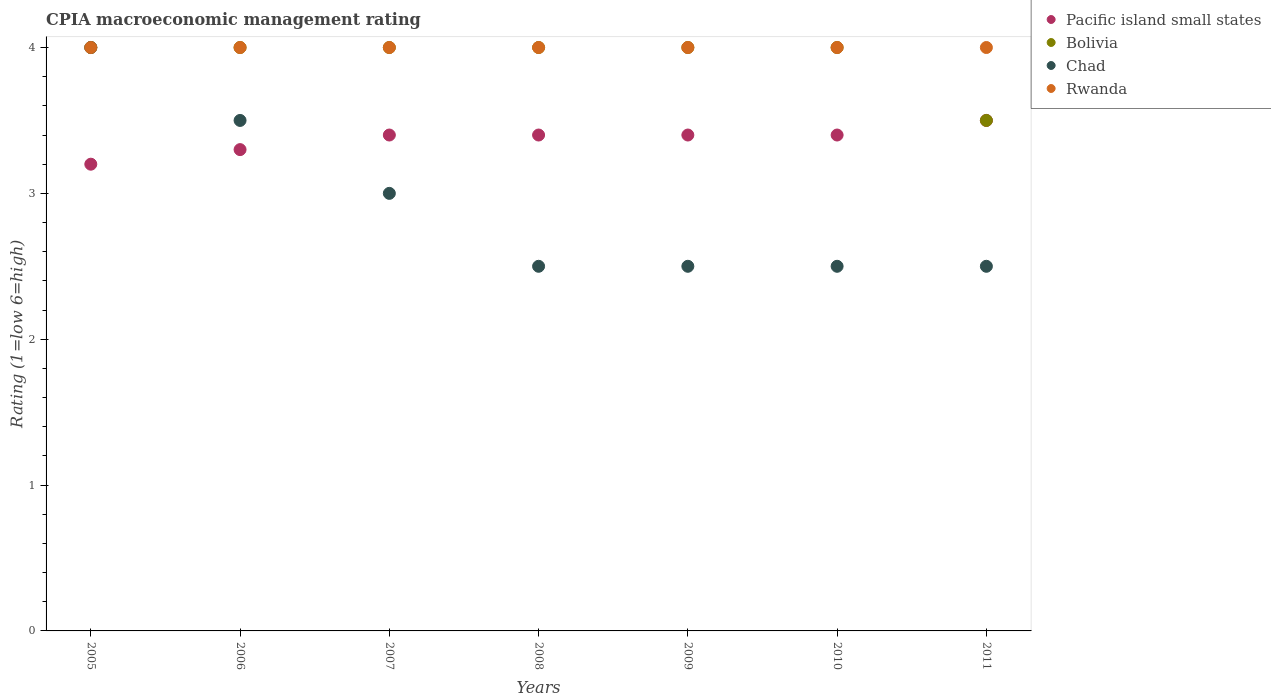Is the number of dotlines equal to the number of legend labels?
Your answer should be compact. Yes. What is the CPIA rating in Pacific island small states in 2010?
Ensure brevity in your answer.  3.4. Across all years, what is the minimum CPIA rating in Bolivia?
Ensure brevity in your answer.  3.5. In which year was the CPIA rating in Bolivia maximum?
Make the answer very short. 2005. In which year was the CPIA rating in Pacific island small states minimum?
Give a very brief answer. 2005. What is the total CPIA rating in Chad in the graph?
Provide a succinct answer. 20.5. What is the difference between the CPIA rating in Chad in 2008 and that in 2011?
Make the answer very short. 0. What is the difference between the CPIA rating in Pacific island small states in 2005 and the CPIA rating in Bolivia in 2009?
Your answer should be very brief. -0.8. In how many years, is the CPIA rating in Chad greater than 1.8?
Your answer should be very brief. 7. Is the CPIA rating in Pacific island small states in 2008 less than that in 2009?
Offer a terse response. No. Is the sum of the CPIA rating in Bolivia in 2009 and 2010 greater than the maximum CPIA rating in Chad across all years?
Give a very brief answer. Yes. Is it the case that in every year, the sum of the CPIA rating in Rwanda and CPIA rating in Bolivia  is greater than the sum of CPIA rating in Pacific island small states and CPIA rating in Chad?
Make the answer very short. No. Is it the case that in every year, the sum of the CPIA rating in Chad and CPIA rating in Pacific island small states  is greater than the CPIA rating in Bolivia?
Keep it short and to the point. Yes. Is the CPIA rating in Rwanda strictly greater than the CPIA rating in Chad over the years?
Make the answer very short. No. How many dotlines are there?
Provide a succinct answer. 4. How many years are there in the graph?
Ensure brevity in your answer.  7. What is the difference between two consecutive major ticks on the Y-axis?
Give a very brief answer. 1. Does the graph contain any zero values?
Keep it short and to the point. No. What is the title of the graph?
Ensure brevity in your answer.  CPIA macroeconomic management rating. What is the Rating (1=low 6=high) of Bolivia in 2005?
Provide a succinct answer. 4. What is the Rating (1=low 6=high) in Pacific island small states in 2006?
Your response must be concise. 3.3. What is the Rating (1=low 6=high) in Bolivia in 2006?
Keep it short and to the point. 4. What is the Rating (1=low 6=high) in Chad in 2006?
Offer a terse response. 3.5. What is the Rating (1=low 6=high) in Pacific island small states in 2007?
Your answer should be very brief. 3.4. What is the Rating (1=low 6=high) of Chad in 2008?
Offer a very short reply. 2.5. What is the Rating (1=low 6=high) in Rwanda in 2008?
Make the answer very short. 4. What is the Rating (1=low 6=high) of Pacific island small states in 2009?
Offer a terse response. 3.4. What is the Rating (1=low 6=high) in Rwanda in 2010?
Your answer should be very brief. 4. What is the Rating (1=low 6=high) of Chad in 2011?
Offer a very short reply. 2.5. What is the Rating (1=low 6=high) of Rwanda in 2011?
Offer a terse response. 4. Across all years, what is the maximum Rating (1=low 6=high) in Pacific island small states?
Your answer should be compact. 3.5. Across all years, what is the minimum Rating (1=low 6=high) of Pacific island small states?
Keep it short and to the point. 3.2. Across all years, what is the minimum Rating (1=low 6=high) of Bolivia?
Your answer should be very brief. 3.5. Across all years, what is the minimum Rating (1=low 6=high) of Chad?
Give a very brief answer. 2.5. What is the total Rating (1=low 6=high) in Pacific island small states in the graph?
Keep it short and to the point. 23.6. What is the total Rating (1=low 6=high) in Bolivia in the graph?
Offer a very short reply. 27.5. What is the difference between the Rating (1=low 6=high) of Bolivia in 2005 and that in 2006?
Your response must be concise. 0. What is the difference between the Rating (1=low 6=high) in Rwanda in 2005 and that in 2006?
Ensure brevity in your answer.  0. What is the difference between the Rating (1=low 6=high) of Pacific island small states in 2005 and that in 2007?
Ensure brevity in your answer.  -0.2. What is the difference between the Rating (1=low 6=high) in Bolivia in 2005 and that in 2007?
Provide a short and direct response. 0. What is the difference between the Rating (1=low 6=high) in Chad in 2005 and that in 2007?
Your answer should be compact. 1. What is the difference between the Rating (1=low 6=high) in Pacific island small states in 2005 and that in 2008?
Your answer should be very brief. -0.2. What is the difference between the Rating (1=low 6=high) in Rwanda in 2005 and that in 2008?
Keep it short and to the point. 0. What is the difference between the Rating (1=low 6=high) in Pacific island small states in 2005 and that in 2009?
Offer a very short reply. -0.2. What is the difference between the Rating (1=low 6=high) in Bolivia in 2005 and that in 2009?
Provide a succinct answer. 0. What is the difference between the Rating (1=low 6=high) in Chad in 2005 and that in 2009?
Make the answer very short. 1.5. What is the difference between the Rating (1=low 6=high) in Chad in 2005 and that in 2010?
Offer a terse response. 1.5. What is the difference between the Rating (1=low 6=high) of Rwanda in 2005 and that in 2010?
Your answer should be very brief. 0. What is the difference between the Rating (1=low 6=high) of Chad in 2005 and that in 2011?
Your response must be concise. 1.5. What is the difference between the Rating (1=low 6=high) of Rwanda in 2005 and that in 2011?
Offer a terse response. 0. What is the difference between the Rating (1=low 6=high) in Pacific island small states in 2006 and that in 2007?
Your response must be concise. -0.1. What is the difference between the Rating (1=low 6=high) in Chad in 2006 and that in 2007?
Your response must be concise. 0.5. What is the difference between the Rating (1=low 6=high) in Rwanda in 2006 and that in 2007?
Your response must be concise. 0. What is the difference between the Rating (1=low 6=high) of Bolivia in 2006 and that in 2008?
Provide a short and direct response. 0. What is the difference between the Rating (1=low 6=high) in Chad in 2006 and that in 2008?
Offer a terse response. 1. What is the difference between the Rating (1=low 6=high) in Bolivia in 2006 and that in 2009?
Give a very brief answer. 0. What is the difference between the Rating (1=low 6=high) in Rwanda in 2006 and that in 2009?
Provide a succinct answer. 0. What is the difference between the Rating (1=low 6=high) of Bolivia in 2006 and that in 2011?
Your answer should be compact. 0.5. What is the difference between the Rating (1=low 6=high) of Bolivia in 2007 and that in 2008?
Your response must be concise. 0. What is the difference between the Rating (1=low 6=high) of Chad in 2007 and that in 2008?
Provide a succinct answer. 0.5. What is the difference between the Rating (1=low 6=high) in Bolivia in 2007 and that in 2009?
Offer a very short reply. 0. What is the difference between the Rating (1=low 6=high) of Pacific island small states in 2007 and that in 2010?
Provide a short and direct response. 0. What is the difference between the Rating (1=low 6=high) in Bolivia in 2007 and that in 2010?
Provide a succinct answer. 0. What is the difference between the Rating (1=low 6=high) in Chad in 2007 and that in 2010?
Offer a very short reply. 0.5. What is the difference between the Rating (1=low 6=high) in Rwanda in 2007 and that in 2010?
Keep it short and to the point. 0. What is the difference between the Rating (1=low 6=high) of Bolivia in 2007 and that in 2011?
Your answer should be very brief. 0.5. What is the difference between the Rating (1=low 6=high) in Chad in 2007 and that in 2011?
Your answer should be compact. 0.5. What is the difference between the Rating (1=low 6=high) of Rwanda in 2007 and that in 2011?
Your answer should be compact. 0. What is the difference between the Rating (1=low 6=high) of Pacific island small states in 2008 and that in 2009?
Provide a short and direct response. 0. What is the difference between the Rating (1=low 6=high) of Bolivia in 2008 and that in 2009?
Your answer should be very brief. 0. What is the difference between the Rating (1=low 6=high) of Chad in 2008 and that in 2009?
Provide a succinct answer. 0. What is the difference between the Rating (1=low 6=high) in Pacific island small states in 2008 and that in 2010?
Ensure brevity in your answer.  0. What is the difference between the Rating (1=low 6=high) of Bolivia in 2008 and that in 2010?
Make the answer very short. 0. What is the difference between the Rating (1=low 6=high) in Bolivia in 2008 and that in 2011?
Your answer should be very brief. 0.5. What is the difference between the Rating (1=low 6=high) of Rwanda in 2008 and that in 2011?
Offer a very short reply. 0. What is the difference between the Rating (1=low 6=high) in Pacific island small states in 2009 and that in 2010?
Keep it short and to the point. 0. What is the difference between the Rating (1=low 6=high) in Bolivia in 2009 and that in 2010?
Your response must be concise. 0. What is the difference between the Rating (1=low 6=high) of Chad in 2009 and that in 2010?
Keep it short and to the point. 0. What is the difference between the Rating (1=low 6=high) of Rwanda in 2009 and that in 2010?
Offer a terse response. 0. What is the difference between the Rating (1=low 6=high) of Pacific island small states in 2009 and that in 2011?
Your answer should be compact. -0.1. What is the difference between the Rating (1=low 6=high) in Chad in 2009 and that in 2011?
Give a very brief answer. 0. What is the difference between the Rating (1=low 6=high) in Rwanda in 2009 and that in 2011?
Your response must be concise. 0. What is the difference between the Rating (1=low 6=high) of Bolivia in 2010 and that in 2011?
Offer a terse response. 0.5. What is the difference between the Rating (1=low 6=high) in Chad in 2010 and that in 2011?
Offer a very short reply. 0. What is the difference between the Rating (1=low 6=high) of Rwanda in 2010 and that in 2011?
Provide a short and direct response. 0. What is the difference between the Rating (1=low 6=high) of Pacific island small states in 2005 and the Rating (1=low 6=high) of Bolivia in 2006?
Provide a short and direct response. -0.8. What is the difference between the Rating (1=low 6=high) in Bolivia in 2005 and the Rating (1=low 6=high) in Chad in 2006?
Your answer should be very brief. 0.5. What is the difference between the Rating (1=low 6=high) of Pacific island small states in 2005 and the Rating (1=low 6=high) of Bolivia in 2007?
Ensure brevity in your answer.  -0.8. What is the difference between the Rating (1=low 6=high) of Pacific island small states in 2005 and the Rating (1=low 6=high) of Rwanda in 2007?
Offer a terse response. -0.8. What is the difference between the Rating (1=low 6=high) in Bolivia in 2005 and the Rating (1=low 6=high) in Chad in 2007?
Make the answer very short. 1. What is the difference between the Rating (1=low 6=high) in Pacific island small states in 2005 and the Rating (1=low 6=high) in Bolivia in 2008?
Offer a terse response. -0.8. What is the difference between the Rating (1=low 6=high) of Pacific island small states in 2005 and the Rating (1=low 6=high) of Rwanda in 2008?
Your response must be concise. -0.8. What is the difference between the Rating (1=low 6=high) of Bolivia in 2005 and the Rating (1=low 6=high) of Chad in 2008?
Offer a very short reply. 1.5. What is the difference between the Rating (1=low 6=high) in Bolivia in 2005 and the Rating (1=low 6=high) in Rwanda in 2008?
Offer a terse response. 0. What is the difference between the Rating (1=low 6=high) in Chad in 2005 and the Rating (1=low 6=high) in Rwanda in 2008?
Provide a short and direct response. 0. What is the difference between the Rating (1=low 6=high) of Pacific island small states in 2005 and the Rating (1=low 6=high) of Bolivia in 2009?
Keep it short and to the point. -0.8. What is the difference between the Rating (1=low 6=high) of Pacific island small states in 2005 and the Rating (1=low 6=high) of Chad in 2009?
Your response must be concise. 0.7. What is the difference between the Rating (1=low 6=high) of Bolivia in 2005 and the Rating (1=low 6=high) of Chad in 2009?
Ensure brevity in your answer.  1.5. What is the difference between the Rating (1=low 6=high) in Pacific island small states in 2005 and the Rating (1=low 6=high) in Bolivia in 2010?
Ensure brevity in your answer.  -0.8. What is the difference between the Rating (1=low 6=high) in Pacific island small states in 2005 and the Rating (1=low 6=high) in Rwanda in 2010?
Your answer should be very brief. -0.8. What is the difference between the Rating (1=low 6=high) of Chad in 2005 and the Rating (1=low 6=high) of Rwanda in 2010?
Provide a succinct answer. 0. What is the difference between the Rating (1=low 6=high) of Pacific island small states in 2005 and the Rating (1=low 6=high) of Bolivia in 2011?
Offer a very short reply. -0.3. What is the difference between the Rating (1=low 6=high) of Pacific island small states in 2005 and the Rating (1=low 6=high) of Rwanda in 2011?
Make the answer very short. -0.8. What is the difference between the Rating (1=low 6=high) in Bolivia in 2005 and the Rating (1=low 6=high) in Chad in 2011?
Offer a terse response. 1.5. What is the difference between the Rating (1=low 6=high) in Bolivia in 2005 and the Rating (1=low 6=high) in Rwanda in 2011?
Offer a terse response. 0. What is the difference between the Rating (1=low 6=high) in Pacific island small states in 2006 and the Rating (1=low 6=high) in Bolivia in 2007?
Your response must be concise. -0.7. What is the difference between the Rating (1=low 6=high) of Pacific island small states in 2006 and the Rating (1=low 6=high) of Chad in 2007?
Make the answer very short. 0.3. What is the difference between the Rating (1=low 6=high) of Bolivia in 2006 and the Rating (1=low 6=high) of Rwanda in 2007?
Keep it short and to the point. 0. What is the difference between the Rating (1=low 6=high) in Pacific island small states in 2006 and the Rating (1=low 6=high) in Rwanda in 2008?
Offer a very short reply. -0.7. What is the difference between the Rating (1=low 6=high) of Bolivia in 2006 and the Rating (1=low 6=high) of Rwanda in 2008?
Give a very brief answer. 0. What is the difference between the Rating (1=low 6=high) in Pacific island small states in 2006 and the Rating (1=low 6=high) in Bolivia in 2009?
Offer a very short reply. -0.7. What is the difference between the Rating (1=low 6=high) of Bolivia in 2006 and the Rating (1=low 6=high) of Chad in 2009?
Your answer should be very brief. 1.5. What is the difference between the Rating (1=low 6=high) in Bolivia in 2006 and the Rating (1=low 6=high) in Rwanda in 2009?
Offer a terse response. 0. What is the difference between the Rating (1=low 6=high) in Chad in 2006 and the Rating (1=low 6=high) in Rwanda in 2009?
Your response must be concise. -0.5. What is the difference between the Rating (1=low 6=high) in Pacific island small states in 2006 and the Rating (1=low 6=high) in Bolivia in 2010?
Keep it short and to the point. -0.7. What is the difference between the Rating (1=low 6=high) in Pacific island small states in 2006 and the Rating (1=low 6=high) in Rwanda in 2010?
Your answer should be very brief. -0.7. What is the difference between the Rating (1=low 6=high) of Bolivia in 2006 and the Rating (1=low 6=high) of Chad in 2010?
Your answer should be very brief. 1.5. What is the difference between the Rating (1=low 6=high) in Pacific island small states in 2006 and the Rating (1=low 6=high) in Bolivia in 2011?
Provide a succinct answer. -0.2. What is the difference between the Rating (1=low 6=high) of Bolivia in 2006 and the Rating (1=low 6=high) of Rwanda in 2011?
Provide a short and direct response. 0. What is the difference between the Rating (1=low 6=high) of Chad in 2006 and the Rating (1=low 6=high) of Rwanda in 2011?
Your response must be concise. -0.5. What is the difference between the Rating (1=low 6=high) of Pacific island small states in 2007 and the Rating (1=low 6=high) of Chad in 2008?
Your answer should be compact. 0.9. What is the difference between the Rating (1=low 6=high) in Pacific island small states in 2007 and the Rating (1=low 6=high) in Rwanda in 2008?
Offer a very short reply. -0.6. What is the difference between the Rating (1=low 6=high) of Chad in 2007 and the Rating (1=low 6=high) of Rwanda in 2008?
Keep it short and to the point. -1. What is the difference between the Rating (1=low 6=high) of Pacific island small states in 2007 and the Rating (1=low 6=high) of Chad in 2009?
Give a very brief answer. 0.9. What is the difference between the Rating (1=low 6=high) in Bolivia in 2007 and the Rating (1=low 6=high) in Chad in 2009?
Offer a terse response. 1.5. What is the difference between the Rating (1=low 6=high) in Bolivia in 2007 and the Rating (1=low 6=high) in Rwanda in 2009?
Keep it short and to the point. 0. What is the difference between the Rating (1=low 6=high) of Chad in 2007 and the Rating (1=low 6=high) of Rwanda in 2009?
Ensure brevity in your answer.  -1. What is the difference between the Rating (1=low 6=high) in Pacific island small states in 2007 and the Rating (1=low 6=high) in Bolivia in 2010?
Offer a very short reply. -0.6. What is the difference between the Rating (1=low 6=high) in Pacific island small states in 2007 and the Rating (1=low 6=high) in Chad in 2010?
Keep it short and to the point. 0.9. What is the difference between the Rating (1=low 6=high) of Pacific island small states in 2007 and the Rating (1=low 6=high) of Rwanda in 2010?
Your response must be concise. -0.6. What is the difference between the Rating (1=low 6=high) in Bolivia in 2007 and the Rating (1=low 6=high) in Chad in 2010?
Give a very brief answer. 1.5. What is the difference between the Rating (1=low 6=high) in Bolivia in 2007 and the Rating (1=low 6=high) in Rwanda in 2010?
Offer a terse response. 0. What is the difference between the Rating (1=low 6=high) of Pacific island small states in 2007 and the Rating (1=low 6=high) of Rwanda in 2011?
Make the answer very short. -0.6. What is the difference between the Rating (1=low 6=high) of Bolivia in 2007 and the Rating (1=low 6=high) of Rwanda in 2011?
Provide a succinct answer. 0. What is the difference between the Rating (1=low 6=high) in Pacific island small states in 2008 and the Rating (1=low 6=high) in Rwanda in 2009?
Offer a very short reply. -0.6. What is the difference between the Rating (1=low 6=high) of Bolivia in 2008 and the Rating (1=low 6=high) of Rwanda in 2009?
Offer a very short reply. 0. What is the difference between the Rating (1=low 6=high) of Pacific island small states in 2008 and the Rating (1=low 6=high) of Bolivia in 2010?
Provide a short and direct response. -0.6. What is the difference between the Rating (1=low 6=high) of Pacific island small states in 2008 and the Rating (1=low 6=high) of Chad in 2010?
Provide a succinct answer. 0.9. What is the difference between the Rating (1=low 6=high) in Bolivia in 2008 and the Rating (1=low 6=high) in Rwanda in 2010?
Give a very brief answer. 0. What is the difference between the Rating (1=low 6=high) of Pacific island small states in 2008 and the Rating (1=low 6=high) of Bolivia in 2011?
Provide a short and direct response. -0.1. What is the difference between the Rating (1=low 6=high) in Pacific island small states in 2008 and the Rating (1=low 6=high) in Rwanda in 2011?
Offer a terse response. -0.6. What is the difference between the Rating (1=low 6=high) of Bolivia in 2008 and the Rating (1=low 6=high) of Chad in 2011?
Ensure brevity in your answer.  1.5. What is the difference between the Rating (1=low 6=high) of Chad in 2008 and the Rating (1=low 6=high) of Rwanda in 2011?
Ensure brevity in your answer.  -1.5. What is the difference between the Rating (1=low 6=high) in Pacific island small states in 2009 and the Rating (1=low 6=high) in Chad in 2010?
Provide a short and direct response. 0.9. What is the difference between the Rating (1=low 6=high) of Pacific island small states in 2009 and the Rating (1=low 6=high) of Chad in 2011?
Ensure brevity in your answer.  0.9. What is the difference between the Rating (1=low 6=high) of Chad in 2009 and the Rating (1=low 6=high) of Rwanda in 2011?
Make the answer very short. -1.5. What is the difference between the Rating (1=low 6=high) in Pacific island small states in 2010 and the Rating (1=low 6=high) in Bolivia in 2011?
Give a very brief answer. -0.1. What is the difference between the Rating (1=low 6=high) in Bolivia in 2010 and the Rating (1=low 6=high) in Chad in 2011?
Offer a very short reply. 1.5. What is the average Rating (1=low 6=high) in Pacific island small states per year?
Offer a very short reply. 3.37. What is the average Rating (1=low 6=high) in Bolivia per year?
Your response must be concise. 3.93. What is the average Rating (1=low 6=high) of Chad per year?
Make the answer very short. 2.93. What is the average Rating (1=low 6=high) of Rwanda per year?
Give a very brief answer. 4. In the year 2005, what is the difference between the Rating (1=low 6=high) in Pacific island small states and Rating (1=low 6=high) in Bolivia?
Provide a succinct answer. -0.8. In the year 2005, what is the difference between the Rating (1=low 6=high) of Pacific island small states and Rating (1=low 6=high) of Chad?
Keep it short and to the point. -0.8. In the year 2006, what is the difference between the Rating (1=low 6=high) of Pacific island small states and Rating (1=low 6=high) of Bolivia?
Provide a succinct answer. -0.7. In the year 2006, what is the difference between the Rating (1=low 6=high) of Pacific island small states and Rating (1=low 6=high) of Chad?
Offer a terse response. -0.2. In the year 2006, what is the difference between the Rating (1=low 6=high) in Pacific island small states and Rating (1=low 6=high) in Rwanda?
Keep it short and to the point. -0.7. In the year 2006, what is the difference between the Rating (1=low 6=high) in Chad and Rating (1=low 6=high) in Rwanda?
Make the answer very short. -0.5. In the year 2007, what is the difference between the Rating (1=low 6=high) in Pacific island small states and Rating (1=low 6=high) in Bolivia?
Give a very brief answer. -0.6. In the year 2007, what is the difference between the Rating (1=low 6=high) in Bolivia and Rating (1=low 6=high) in Rwanda?
Provide a short and direct response. 0. In the year 2008, what is the difference between the Rating (1=low 6=high) in Bolivia and Rating (1=low 6=high) in Chad?
Provide a succinct answer. 1.5. In the year 2008, what is the difference between the Rating (1=low 6=high) in Bolivia and Rating (1=low 6=high) in Rwanda?
Give a very brief answer. 0. In the year 2009, what is the difference between the Rating (1=low 6=high) in Pacific island small states and Rating (1=low 6=high) in Bolivia?
Offer a terse response. -0.6. In the year 2009, what is the difference between the Rating (1=low 6=high) in Bolivia and Rating (1=low 6=high) in Rwanda?
Give a very brief answer. 0. In the year 2010, what is the difference between the Rating (1=low 6=high) in Pacific island small states and Rating (1=low 6=high) in Bolivia?
Make the answer very short. -0.6. In the year 2010, what is the difference between the Rating (1=low 6=high) of Chad and Rating (1=low 6=high) of Rwanda?
Give a very brief answer. -1.5. In the year 2011, what is the difference between the Rating (1=low 6=high) in Pacific island small states and Rating (1=low 6=high) in Chad?
Provide a short and direct response. 1. In the year 2011, what is the difference between the Rating (1=low 6=high) in Pacific island small states and Rating (1=low 6=high) in Rwanda?
Provide a succinct answer. -0.5. In the year 2011, what is the difference between the Rating (1=low 6=high) of Bolivia and Rating (1=low 6=high) of Rwanda?
Keep it short and to the point. -0.5. In the year 2011, what is the difference between the Rating (1=low 6=high) in Chad and Rating (1=low 6=high) in Rwanda?
Make the answer very short. -1.5. What is the ratio of the Rating (1=low 6=high) of Pacific island small states in 2005 to that in 2006?
Offer a very short reply. 0.97. What is the ratio of the Rating (1=low 6=high) of Bolivia in 2005 to that in 2006?
Your response must be concise. 1. What is the ratio of the Rating (1=low 6=high) in Pacific island small states in 2005 to that in 2007?
Your response must be concise. 0.94. What is the ratio of the Rating (1=low 6=high) of Chad in 2005 to that in 2007?
Give a very brief answer. 1.33. What is the ratio of the Rating (1=low 6=high) in Pacific island small states in 2005 to that in 2008?
Ensure brevity in your answer.  0.94. What is the ratio of the Rating (1=low 6=high) of Chad in 2005 to that in 2008?
Ensure brevity in your answer.  1.6. What is the ratio of the Rating (1=low 6=high) in Pacific island small states in 2005 to that in 2009?
Your answer should be compact. 0.94. What is the ratio of the Rating (1=low 6=high) of Bolivia in 2005 to that in 2009?
Your answer should be compact. 1. What is the ratio of the Rating (1=low 6=high) of Rwanda in 2005 to that in 2010?
Offer a very short reply. 1. What is the ratio of the Rating (1=low 6=high) of Pacific island small states in 2005 to that in 2011?
Your response must be concise. 0.91. What is the ratio of the Rating (1=low 6=high) of Chad in 2005 to that in 2011?
Your response must be concise. 1.6. What is the ratio of the Rating (1=low 6=high) in Rwanda in 2005 to that in 2011?
Your response must be concise. 1. What is the ratio of the Rating (1=low 6=high) of Pacific island small states in 2006 to that in 2007?
Provide a short and direct response. 0.97. What is the ratio of the Rating (1=low 6=high) in Bolivia in 2006 to that in 2007?
Your response must be concise. 1. What is the ratio of the Rating (1=low 6=high) in Rwanda in 2006 to that in 2007?
Make the answer very short. 1. What is the ratio of the Rating (1=low 6=high) of Pacific island small states in 2006 to that in 2008?
Provide a succinct answer. 0.97. What is the ratio of the Rating (1=low 6=high) in Pacific island small states in 2006 to that in 2009?
Your answer should be compact. 0.97. What is the ratio of the Rating (1=low 6=high) of Chad in 2006 to that in 2009?
Make the answer very short. 1.4. What is the ratio of the Rating (1=low 6=high) in Pacific island small states in 2006 to that in 2010?
Provide a succinct answer. 0.97. What is the ratio of the Rating (1=low 6=high) in Rwanda in 2006 to that in 2010?
Ensure brevity in your answer.  1. What is the ratio of the Rating (1=low 6=high) in Pacific island small states in 2006 to that in 2011?
Keep it short and to the point. 0.94. What is the ratio of the Rating (1=low 6=high) in Chad in 2006 to that in 2011?
Your response must be concise. 1.4. What is the ratio of the Rating (1=low 6=high) of Rwanda in 2006 to that in 2011?
Offer a terse response. 1. What is the ratio of the Rating (1=low 6=high) of Pacific island small states in 2007 to that in 2008?
Your response must be concise. 1. What is the ratio of the Rating (1=low 6=high) in Chad in 2007 to that in 2008?
Give a very brief answer. 1.2. What is the ratio of the Rating (1=low 6=high) of Pacific island small states in 2007 to that in 2009?
Provide a short and direct response. 1. What is the ratio of the Rating (1=low 6=high) in Pacific island small states in 2007 to that in 2010?
Make the answer very short. 1. What is the ratio of the Rating (1=low 6=high) in Pacific island small states in 2007 to that in 2011?
Your answer should be very brief. 0.97. What is the ratio of the Rating (1=low 6=high) in Chad in 2007 to that in 2011?
Offer a terse response. 1.2. What is the ratio of the Rating (1=low 6=high) of Pacific island small states in 2008 to that in 2009?
Provide a short and direct response. 1. What is the ratio of the Rating (1=low 6=high) in Rwanda in 2008 to that in 2009?
Provide a succinct answer. 1. What is the ratio of the Rating (1=low 6=high) in Pacific island small states in 2008 to that in 2010?
Your answer should be compact. 1. What is the ratio of the Rating (1=low 6=high) of Rwanda in 2008 to that in 2010?
Ensure brevity in your answer.  1. What is the ratio of the Rating (1=low 6=high) in Pacific island small states in 2008 to that in 2011?
Provide a short and direct response. 0.97. What is the ratio of the Rating (1=low 6=high) in Bolivia in 2008 to that in 2011?
Keep it short and to the point. 1.14. What is the ratio of the Rating (1=low 6=high) of Chad in 2008 to that in 2011?
Provide a short and direct response. 1. What is the ratio of the Rating (1=low 6=high) of Rwanda in 2008 to that in 2011?
Offer a terse response. 1. What is the ratio of the Rating (1=low 6=high) of Chad in 2009 to that in 2010?
Your response must be concise. 1. What is the ratio of the Rating (1=low 6=high) of Rwanda in 2009 to that in 2010?
Your answer should be very brief. 1. What is the ratio of the Rating (1=low 6=high) of Pacific island small states in 2009 to that in 2011?
Keep it short and to the point. 0.97. What is the ratio of the Rating (1=low 6=high) in Bolivia in 2009 to that in 2011?
Make the answer very short. 1.14. What is the ratio of the Rating (1=low 6=high) in Chad in 2009 to that in 2011?
Provide a succinct answer. 1. What is the ratio of the Rating (1=low 6=high) of Rwanda in 2009 to that in 2011?
Your answer should be very brief. 1. What is the ratio of the Rating (1=low 6=high) of Pacific island small states in 2010 to that in 2011?
Provide a succinct answer. 0.97. What is the ratio of the Rating (1=low 6=high) of Bolivia in 2010 to that in 2011?
Keep it short and to the point. 1.14. What is the ratio of the Rating (1=low 6=high) in Chad in 2010 to that in 2011?
Your response must be concise. 1. What is the ratio of the Rating (1=low 6=high) in Rwanda in 2010 to that in 2011?
Make the answer very short. 1. What is the difference between the highest and the second highest Rating (1=low 6=high) in Bolivia?
Your response must be concise. 0. What is the difference between the highest and the second highest Rating (1=low 6=high) in Chad?
Make the answer very short. 0.5. What is the difference between the highest and the lowest Rating (1=low 6=high) of Chad?
Provide a short and direct response. 1.5. 